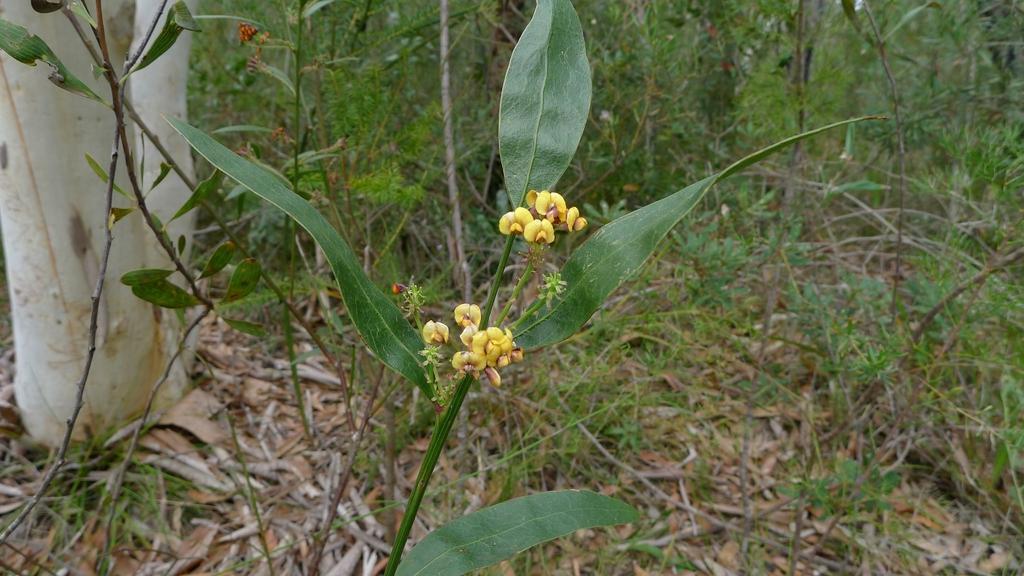In one or two sentences, can you explain what this image depicts? In this picture I can see few flowers and plants, on the left side it looks like the bark of a tree. 